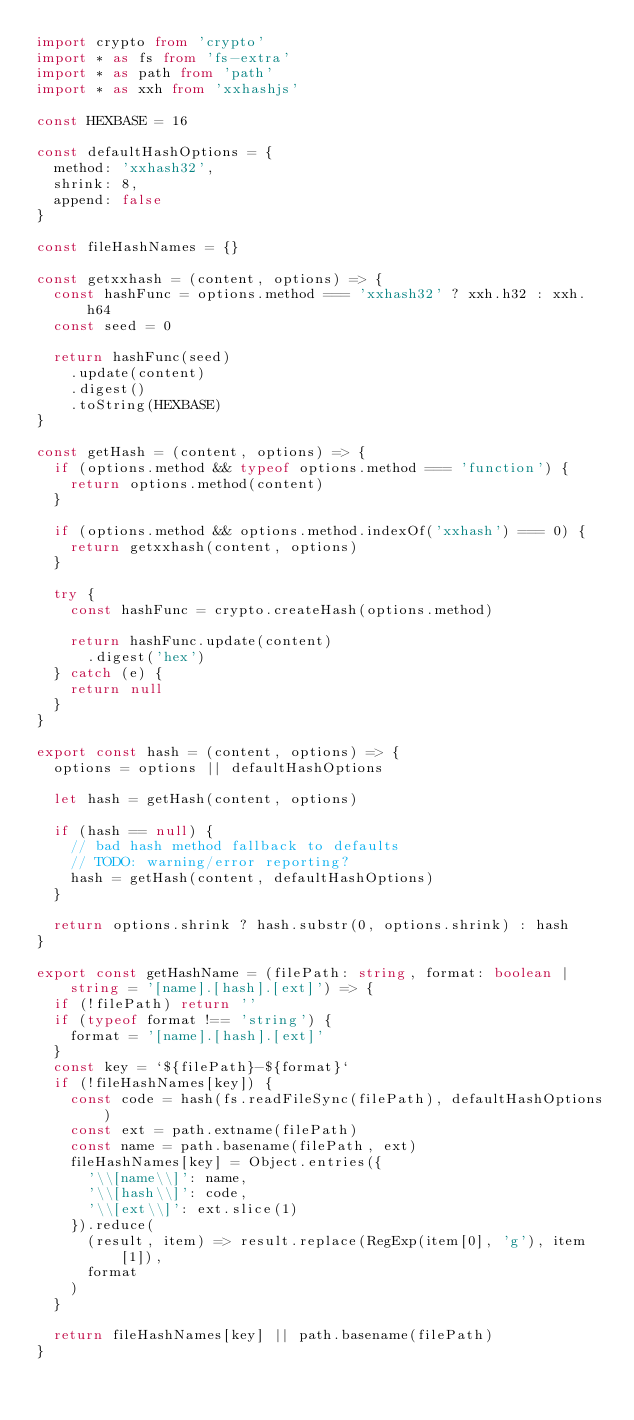<code> <loc_0><loc_0><loc_500><loc_500><_TypeScript_>import crypto from 'crypto'
import * as fs from 'fs-extra'
import * as path from 'path'
import * as xxh from 'xxhashjs'

const HEXBASE = 16

const defaultHashOptions = {
  method: 'xxhash32',
  shrink: 8,
  append: false
}

const fileHashNames = {}

const getxxhash = (content, options) => {
  const hashFunc = options.method === 'xxhash32' ? xxh.h32 : xxh.h64
  const seed = 0

  return hashFunc(seed)
    .update(content)
    .digest()
    .toString(HEXBASE)
}

const getHash = (content, options) => {
  if (options.method && typeof options.method === 'function') {
    return options.method(content)
  }

  if (options.method && options.method.indexOf('xxhash') === 0) {
    return getxxhash(content, options)
  }

  try {
    const hashFunc = crypto.createHash(options.method)

    return hashFunc.update(content)
      .digest('hex')
  } catch (e) {
    return null
  }
}

export const hash = (content, options) => {
  options = options || defaultHashOptions

  let hash = getHash(content, options)

  if (hash == null) {
    // bad hash method fallback to defaults
    // TODO: warning/error reporting?
    hash = getHash(content, defaultHashOptions)
  }

  return options.shrink ? hash.substr(0, options.shrink) : hash
}

export const getHashName = (filePath: string, format: boolean | string = '[name].[hash].[ext]') => {
  if (!filePath) return ''
  if (typeof format !== 'string') {
    format = '[name].[hash].[ext]'
  }
  const key = `${filePath}-${format}`
  if (!fileHashNames[key]) {
    const code = hash(fs.readFileSync(filePath), defaultHashOptions)
    const ext = path.extname(filePath)
    const name = path.basename(filePath, ext)
    fileHashNames[key] = Object.entries({
      '\\[name\\]': name,
      '\\[hash\\]': code,
      '\\[ext\\]': ext.slice(1)
    }).reduce(
      (result, item) => result.replace(RegExp(item[0], 'g'), item[1]),
      format
    )
  }

  return fileHashNames[key] || path.basename(filePath)
}
</code> 